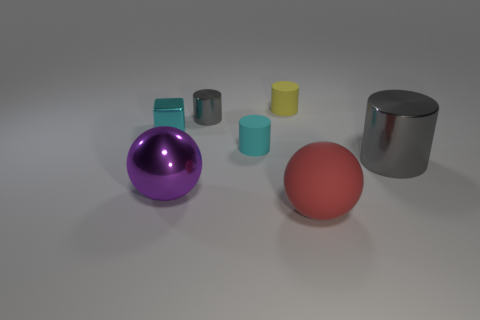Does the yellow cylinder have the same size as the cyan object in front of the tiny cyan metal thing?
Offer a terse response. Yes. Is there anything else that has the same shape as the small cyan metallic thing?
Your response must be concise. No. How many tiny metallic objects are there?
Offer a very short reply. 2. How many red objects are big metal things or large objects?
Your answer should be very brief. 1. Does the sphere that is on the right side of the small yellow cylinder have the same material as the small cyan cube?
Give a very brief answer. No. How many other things are there of the same material as the yellow cylinder?
Ensure brevity in your answer.  2. What is the material of the large gray thing?
Provide a succinct answer. Metal. There is a gray cylinder on the right side of the tiny gray thing; what is its size?
Your answer should be compact. Large. How many large gray metallic things are right of the shiny cylinder that is behind the large cylinder?
Keep it short and to the point. 1. Does the large metallic thing that is right of the large purple sphere have the same shape as the big thing in front of the purple metal sphere?
Your answer should be very brief. No. 